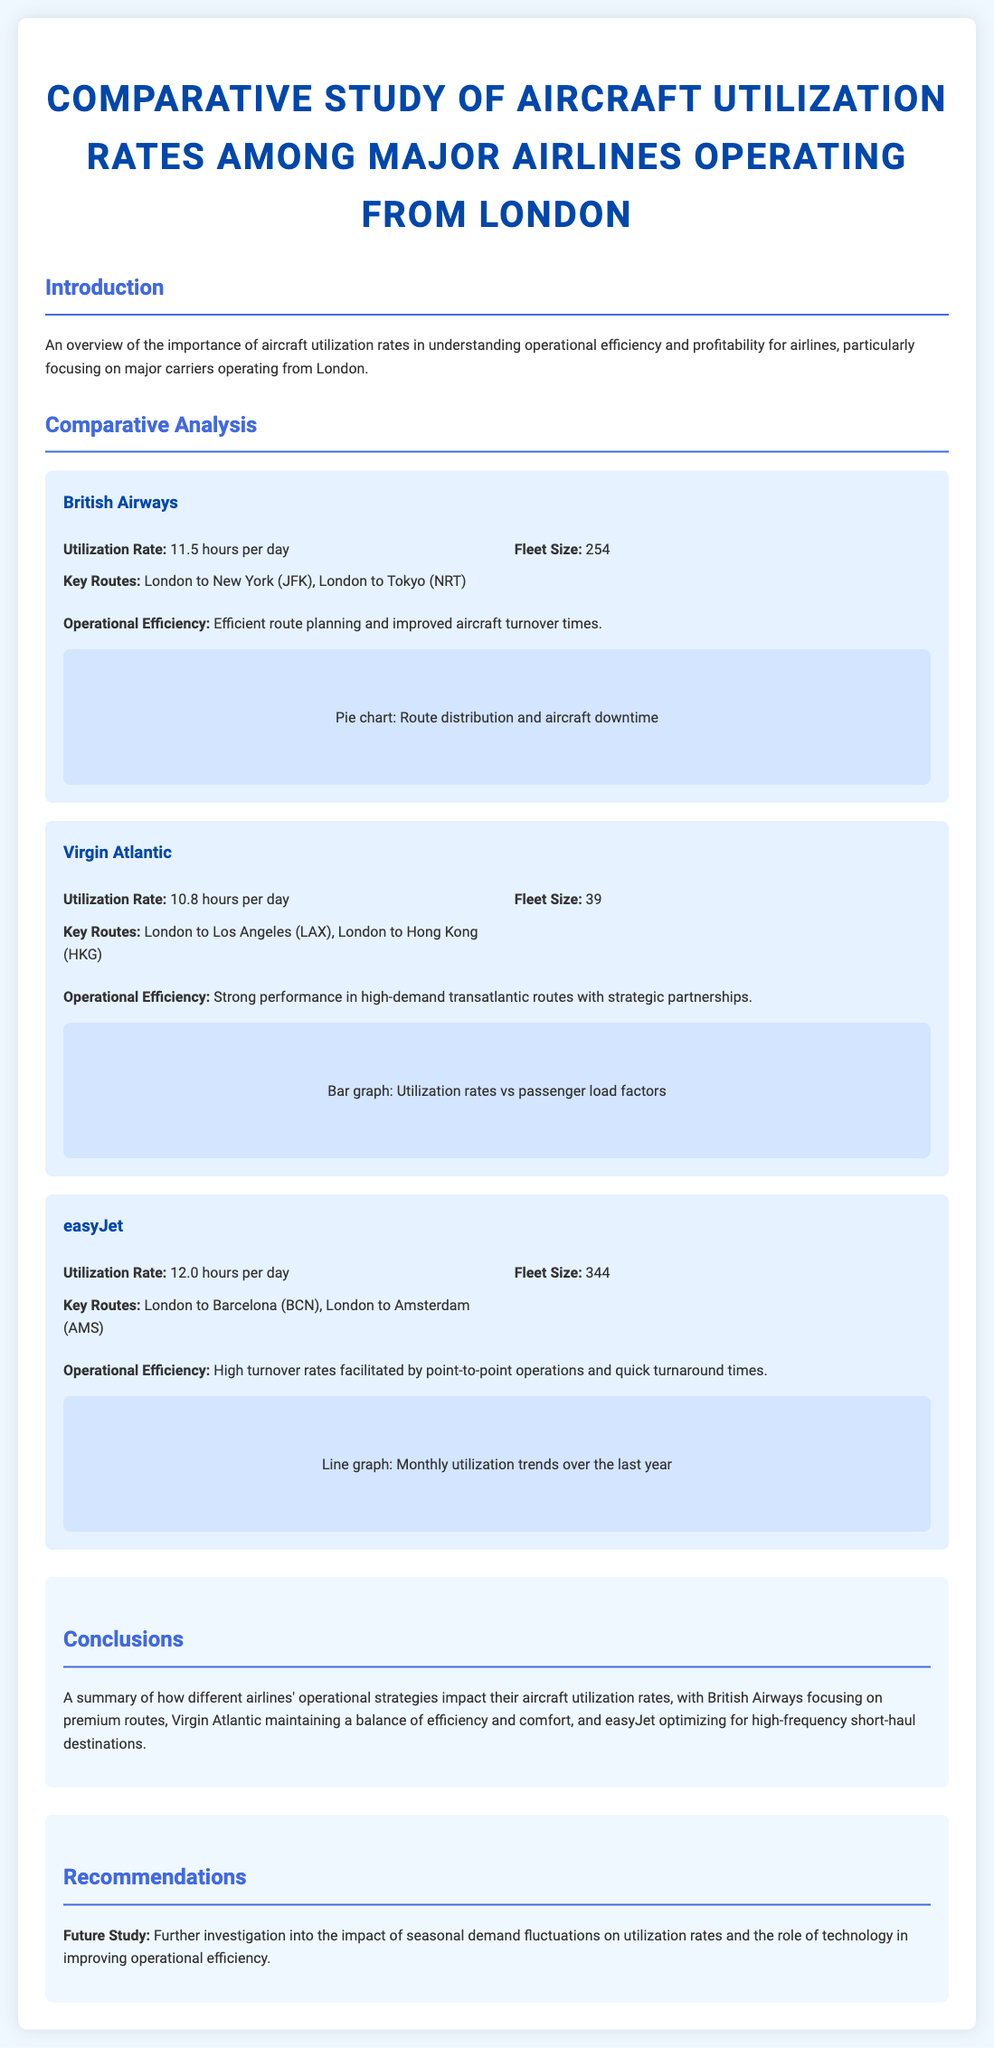What is the utilization rate for British Airways? The utilization rate for British Airways is specifically mentioned in the document as 11.5 hours per day.
Answer: 11.5 hours per day What is easyJet's fleet size? The document provides the fleet size for easyJet, which is 344 aircraft.
Answer: 344 Which airline operates the route London to Los Angeles? The document states that Virgin Atlantic operates the route from London to Los Angeles (LAX).
Answer: Virgin Atlantic What is the operational efficiency focus of easyJet? The operational efficiency for easyJet emphasizes high turnover rates facilitated by point-to-point operations and quick turnaround times.
Answer: High turnover rates How does Virgin Atlantic perform in its market? Virgin Atlantic's performance is strong in high-demand transatlantic routes with strategic partnerships, according to the document.
Answer: Strong performance Which airline has the highest utilization rate? The document specifies that easyJet has the highest utilization rate of 12.0 hours per day compared to the other airlines.
Answer: easyJet What type of graph is used for easyJet's operational efficiency visual representation? The visual representation for easyJet is a line graph focusing on monthly utilization trends over the last year.
Answer: Line graph What is the main conclusion regarding British Airways? The conclusion states that British Airways focuses on premium routes which impacts its aircraft utilization rates.
Answer: Premium routes focus 